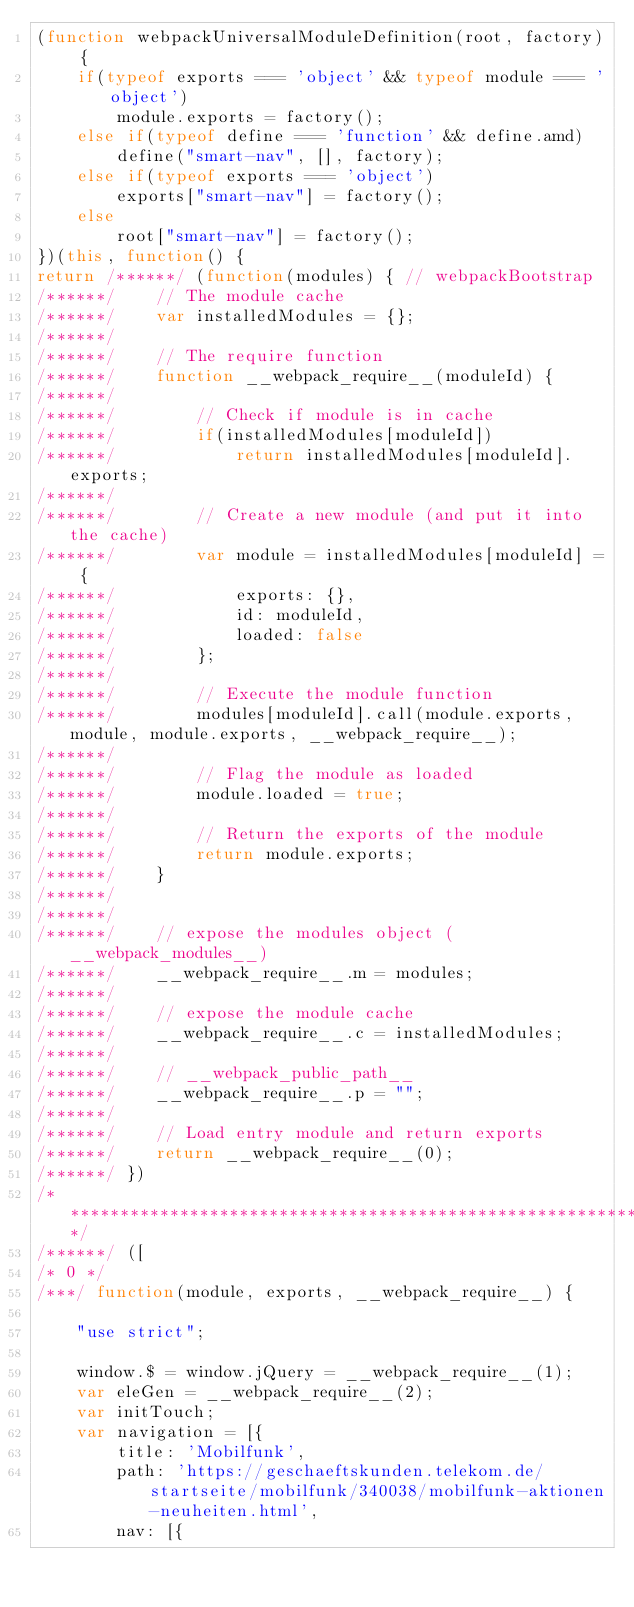<code> <loc_0><loc_0><loc_500><loc_500><_JavaScript_>(function webpackUniversalModuleDefinition(root, factory) {
	if(typeof exports === 'object' && typeof module === 'object')
		module.exports = factory();
	else if(typeof define === 'function' && define.amd)
		define("smart-nav", [], factory);
	else if(typeof exports === 'object')
		exports["smart-nav"] = factory();
	else
		root["smart-nav"] = factory();
})(this, function() {
return /******/ (function(modules) { // webpackBootstrap
/******/ 	// The module cache
/******/ 	var installedModules = {};
/******/
/******/ 	// The require function
/******/ 	function __webpack_require__(moduleId) {
/******/
/******/ 		// Check if module is in cache
/******/ 		if(installedModules[moduleId])
/******/ 			return installedModules[moduleId].exports;
/******/
/******/ 		// Create a new module (and put it into the cache)
/******/ 		var module = installedModules[moduleId] = {
/******/ 			exports: {},
/******/ 			id: moduleId,
/******/ 			loaded: false
/******/ 		};
/******/
/******/ 		// Execute the module function
/******/ 		modules[moduleId].call(module.exports, module, module.exports, __webpack_require__);
/******/
/******/ 		// Flag the module as loaded
/******/ 		module.loaded = true;
/******/
/******/ 		// Return the exports of the module
/******/ 		return module.exports;
/******/ 	}
/******/
/******/
/******/ 	// expose the modules object (__webpack_modules__)
/******/ 	__webpack_require__.m = modules;
/******/
/******/ 	// expose the module cache
/******/ 	__webpack_require__.c = installedModules;
/******/
/******/ 	// __webpack_public_path__
/******/ 	__webpack_require__.p = "";
/******/
/******/ 	// Load entry module and return exports
/******/ 	return __webpack_require__(0);
/******/ })
/************************************************************************/
/******/ ([
/* 0 */
/***/ function(module, exports, __webpack_require__) {

	"use strict";
	
	window.$ = window.jQuery = __webpack_require__(1);
	var eleGen = __webpack_require__(2);
	var initTouch;
	var navigation = [{
	    title: 'Mobilfunk',
	    path: 'https://geschaeftskunden.telekom.de/startseite/mobilfunk/340038/mobilfunk-aktionen-neuheiten.html',
	    nav: [{</code> 